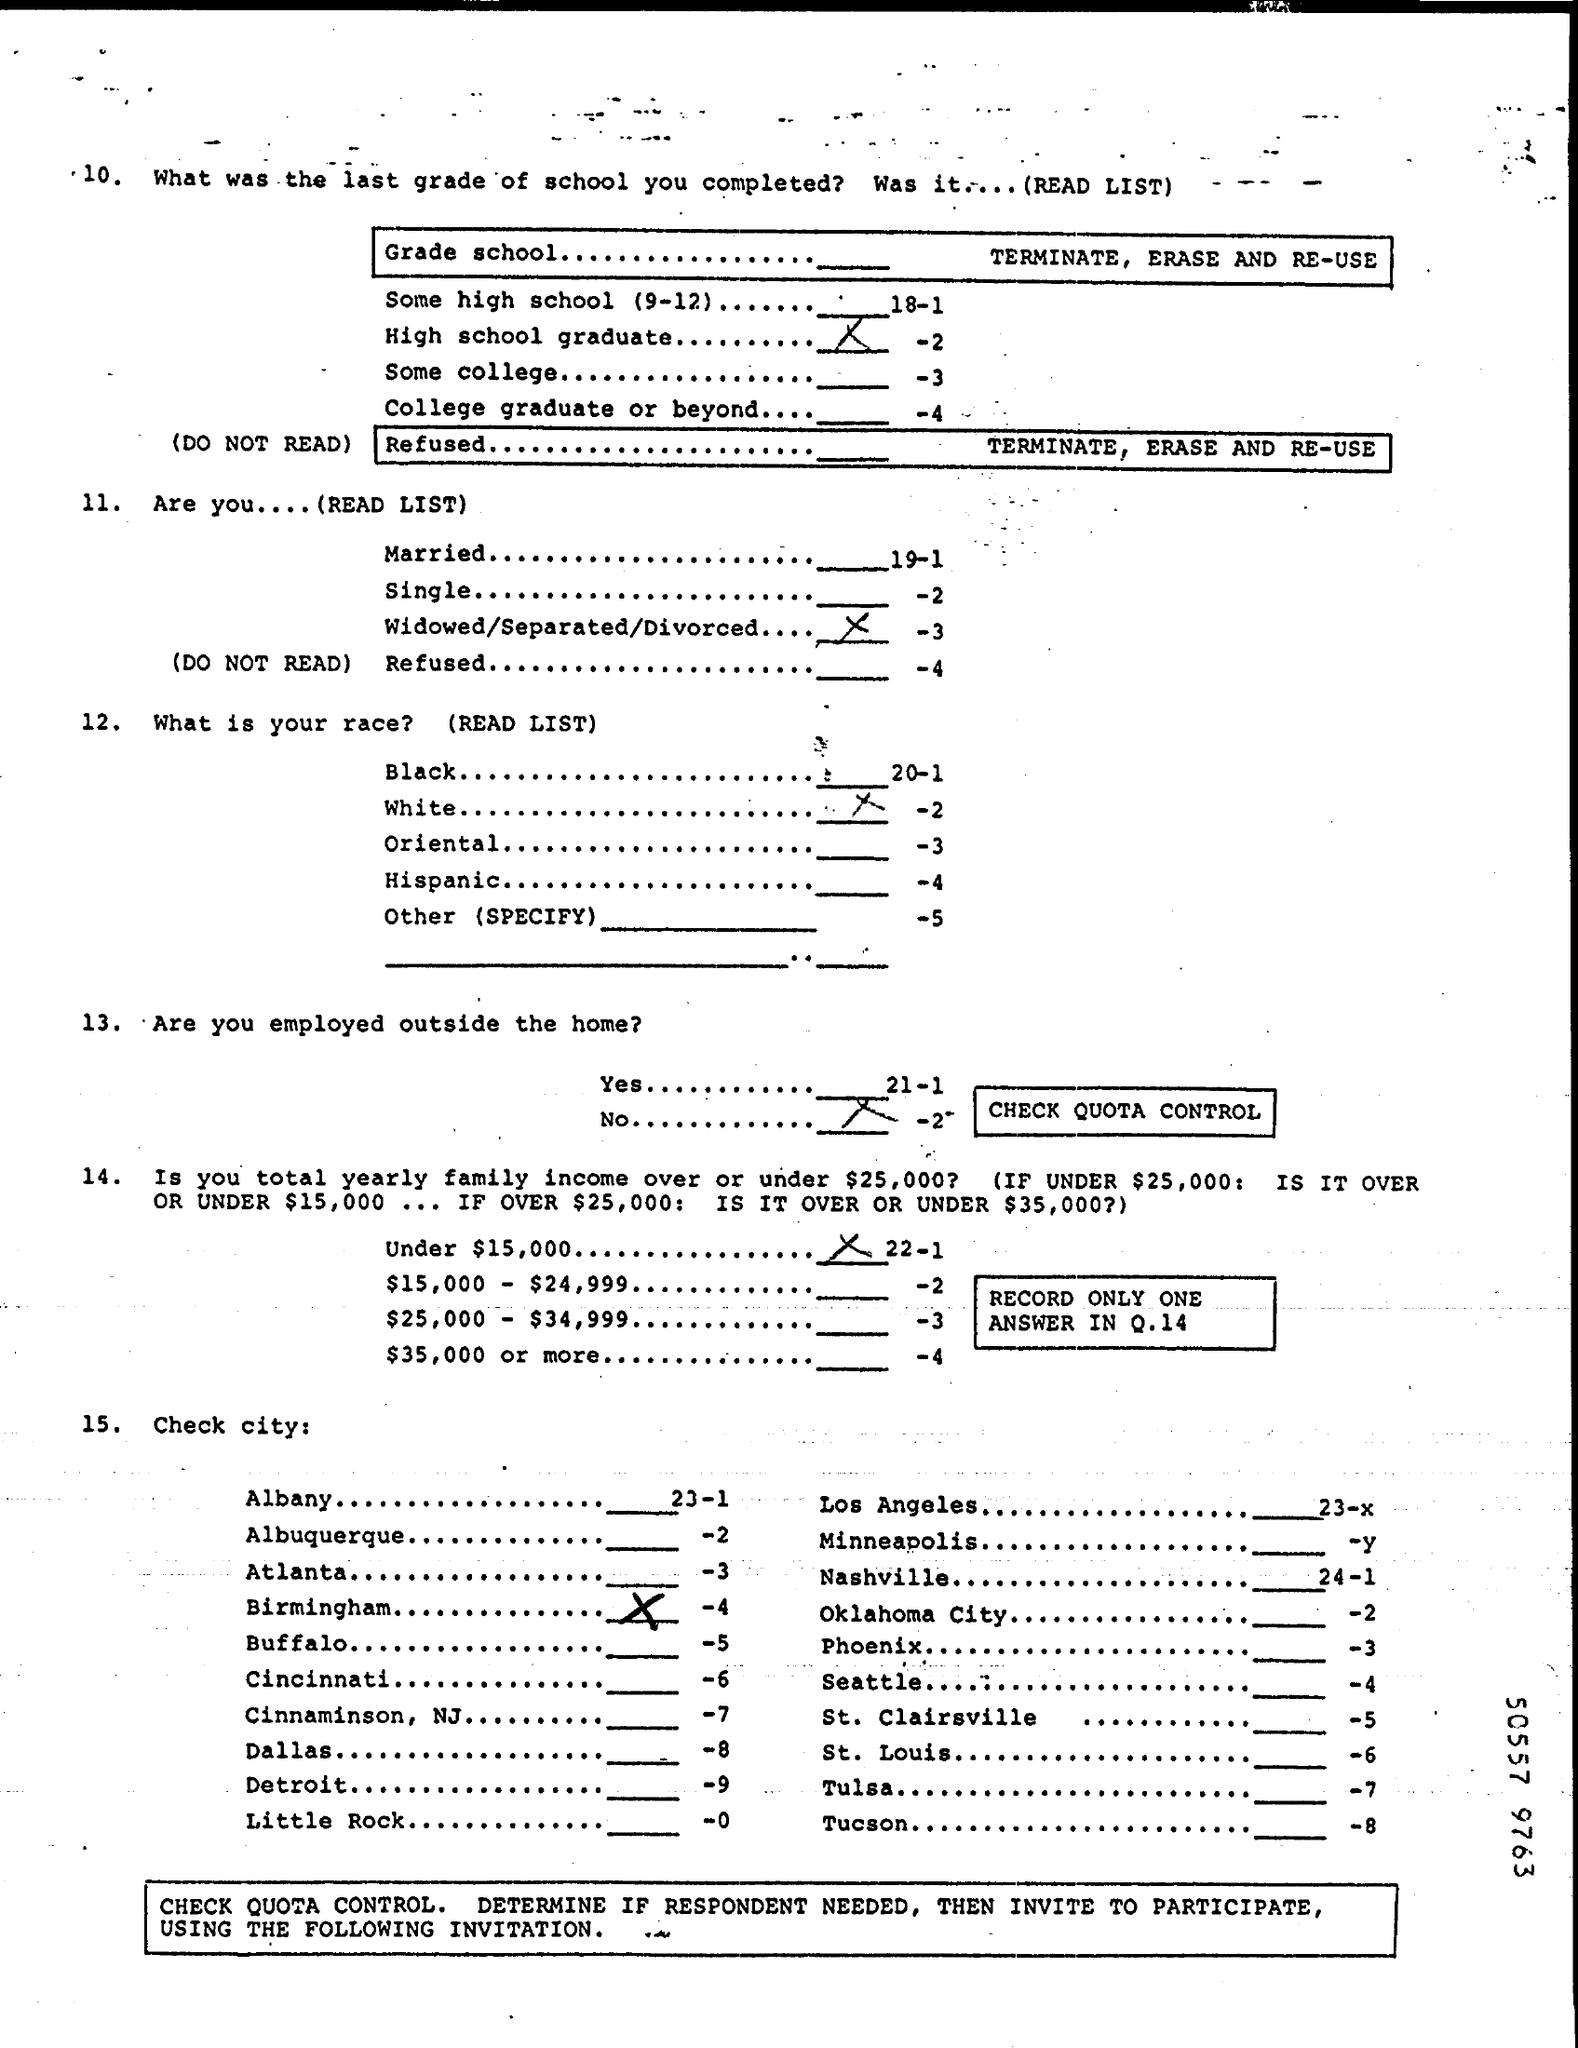What was the last Grade school completed?
Ensure brevity in your answer.  High school Graduate. What is the Total Yearly Family income?
Your answer should be compact. Under $15,000. What is the City?
Your answer should be compact. Birmingham. 